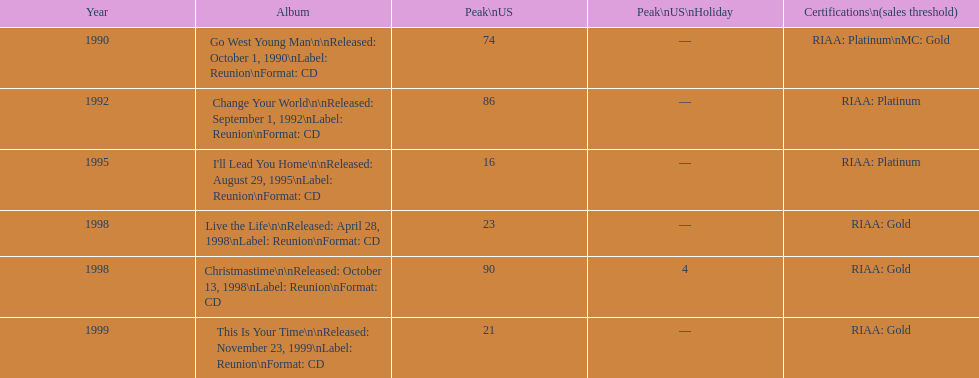What is the earliest year mentioned? 1990. 